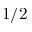Convert formula to latex. <formula><loc_0><loc_0><loc_500><loc_500>1 / 2</formula> 